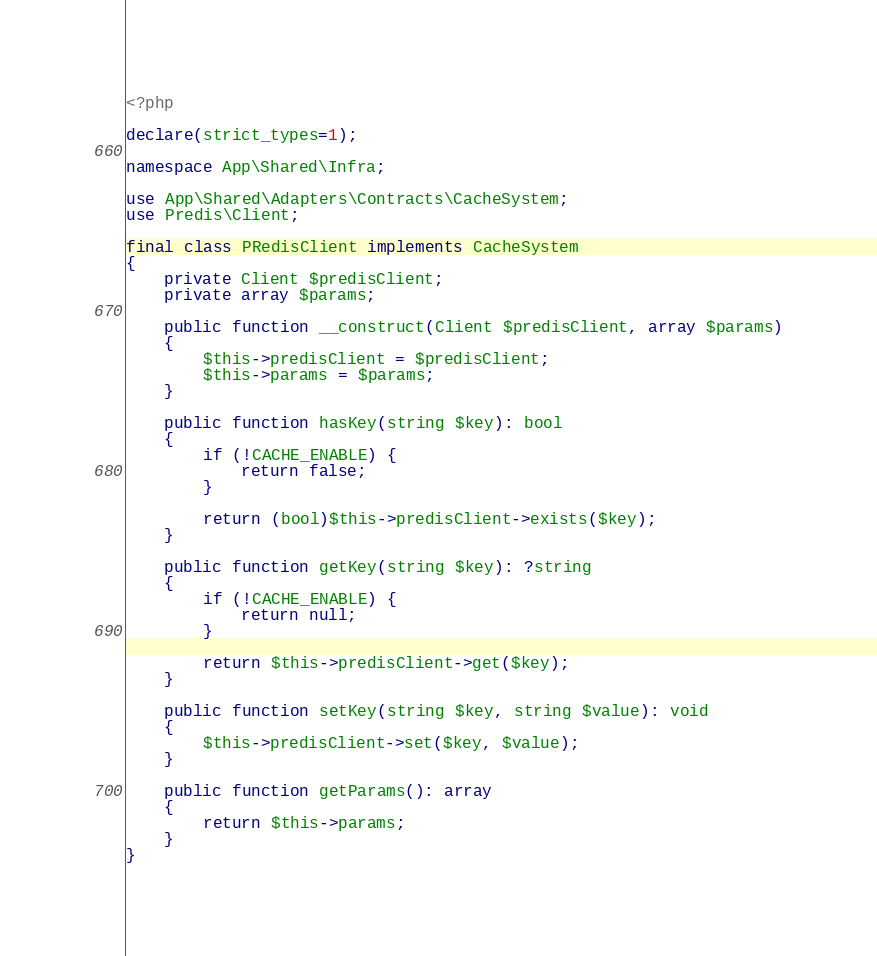<code> <loc_0><loc_0><loc_500><loc_500><_PHP_><?php

declare(strict_types=1);

namespace App\Shared\Infra;

use App\Shared\Adapters\Contracts\CacheSystem;
use Predis\Client;

final class PRedisClient implements CacheSystem
{
    private Client $predisClient;
    private array $params;

    public function __construct(Client $predisClient, array $params)
    {
        $this->predisClient = $predisClient;
        $this->params = $params;
    }

    public function hasKey(string $key): bool
    {
        if (!CACHE_ENABLE) {
            return false;
        }

        return (bool)$this->predisClient->exists($key);
    }

    public function getKey(string $key): ?string
    {
        if (!CACHE_ENABLE) {
            return null;
        }

        return $this->predisClient->get($key);
    }

    public function setKey(string $key, string $value): void
    {
        $this->predisClient->set($key, $value);
    }

    public function getParams(): array
    {
        return $this->params;
    }
}
</code> 